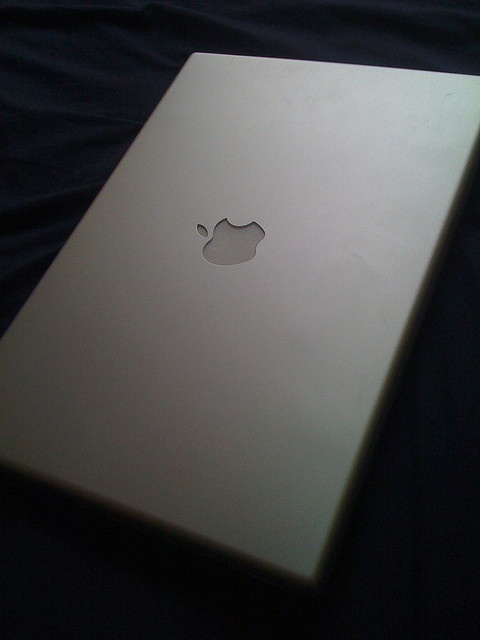Describe the objects in this image and their specific colors. I can see laptop in black, gray, and darkgray tones and apple in black and gray tones in this image. 